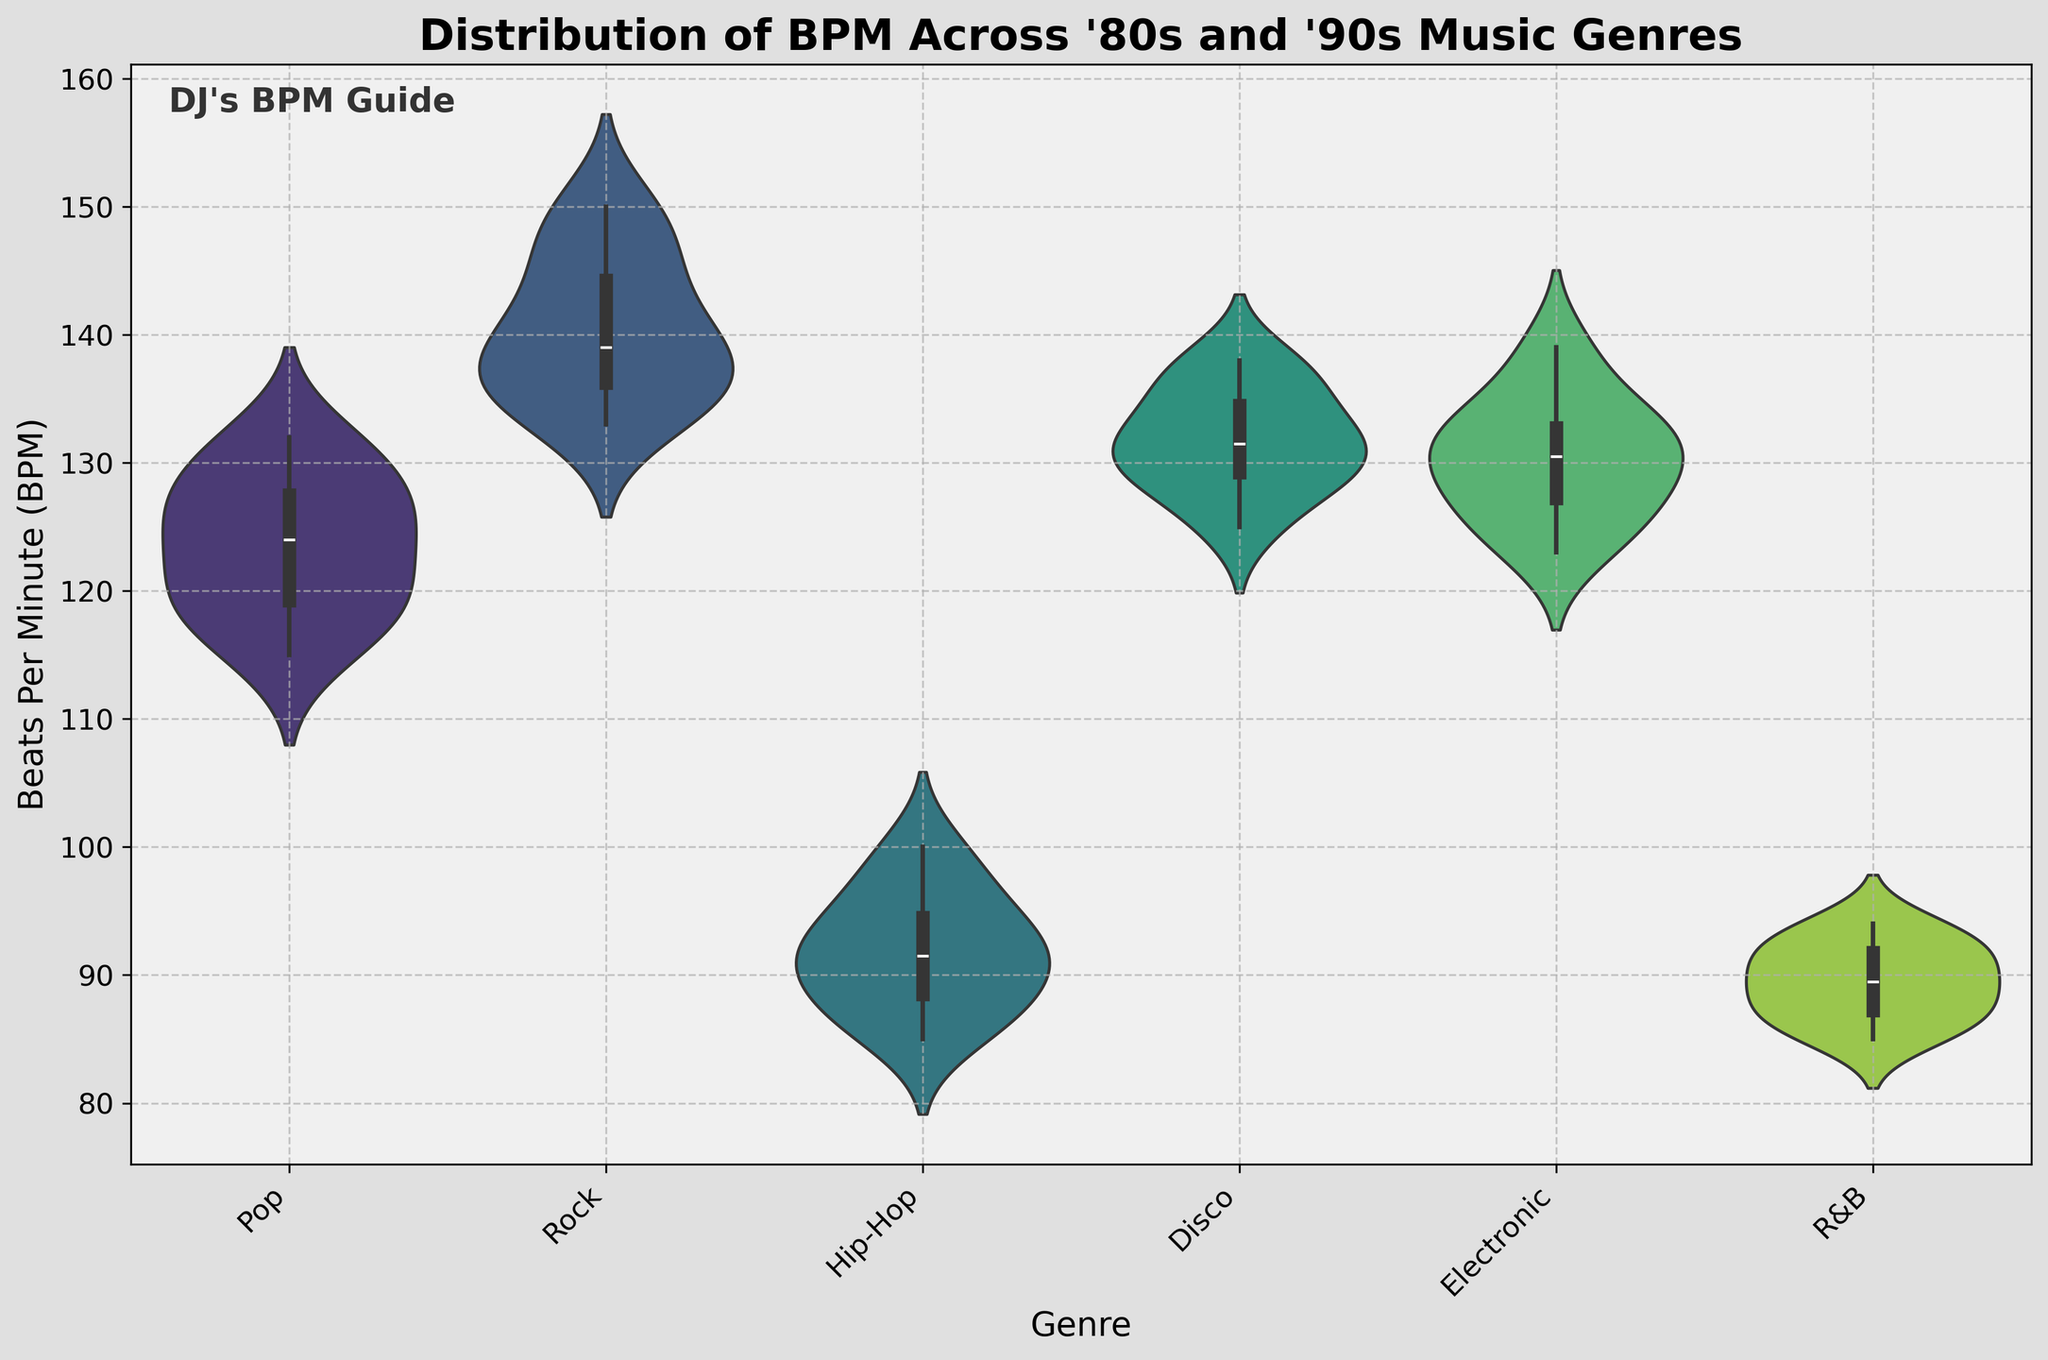What is the title of the plot? The title of the plot is displayed at the top and reads "Distribution of BPM Across '80s and '90s Music Genres."
Answer: Distribution of BPM Across '80s and '90s Music Genres What is the range of BPM for the Rock genre? By observing the width of the violin plot for the Rock genre, the BPM ranges from approximately 133 to 150.
Answer: 133 to 150 Which genre has the lowest median BPM? The median BPM is represented by the center line inside each violin plot. By comparing the center lines, the Hip-Hop genre has the lowest median BPM around 90.
Answer: Hip-Hop How many genres are displayed in the plot? Each genre is labeled on the x-axis, and there are six genres labeled: Pop, Rock, Hip-Hop, Disco, Electronic, and R&B.
Answer: Six Which genre has the widest distribution of BPM? The width of the violin plot indicates the distribution of BPM. The genre with the widest range span appears to be Rock, ranging from about 133 to 150 BPM.
Answer: Rock How do the distributions of BPM in Pop and R&B compare? Pop has a relatively narrow distribution ranging from 115 to 132 BPM, while R&B has a slightly narrower range from 85 to 94 BPM. This indicates that Pop has a slightly wider spread in BPM compared to R&B.
Answer: Pop has a wider spread What's the approximate interquartile range for the Disco genre? The interquartile range (IQR) is represented within the box inside the violin plot. For Disco, the IQR appears to be approximately from 128 to 135 BPM.
Answer: 128 to 135 BPM Which genre shows the highest variability in BPM? Variability can be observed through the combined width and length of each violin plot. Rock shows the highest variability, ranging from 133 to 150 BPM, with a visibly wide and dispersed plot.
Answer: Rock Is the distribution for Electronic more spread out than that of Hip-Hop? By comparing the width and range of the violin plots, Electronic ranges from 123 to 139 BPM, while Hip-Hop ranges from 85 to 100 BPM. The Electronic distribution is more spread out.
Answer: Yes 